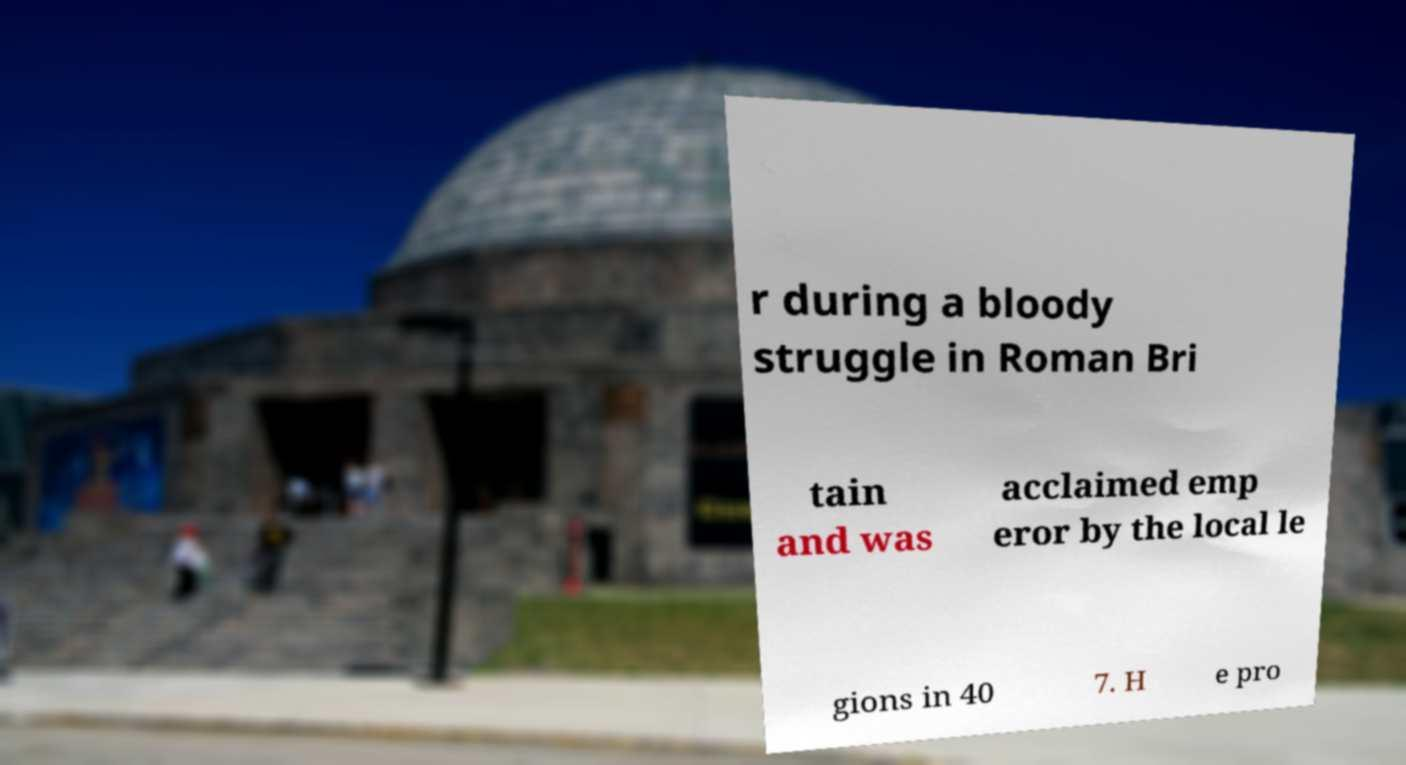Can you read and provide the text displayed in the image?This photo seems to have some interesting text. Can you extract and type it out for me? r during a bloody struggle in Roman Bri tain and was acclaimed emp eror by the local le gions in 40 7. H e pro 